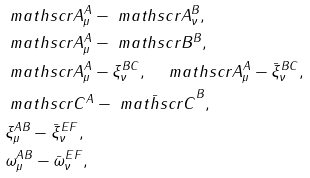<formula> <loc_0><loc_0><loc_500><loc_500>& \ m a t h s c r { A } _ { \mu } ^ { A } - \ m a t h s c r { A } _ { \nu } ^ { B } , \\ & \ m a t h s c r { A } _ { \mu } ^ { A } - \ m a t h s c r { B } ^ { B } , \\ & \ m a t h s c r { A } _ { \mu } ^ { A } - \xi _ { \nu } ^ { B C } , \quad \ m a t h s c r { A } _ { \mu } ^ { A } - \bar { \xi } _ { \nu } ^ { B C } , \\ & \ m a t h s c r { C } ^ { A } - \bar { \ m a t h s c r { C } } ^ { B } , \\ & \xi _ { \mu } ^ { A B } - \bar { \xi } _ { \nu } ^ { E F } , \\ & \omega _ { \mu } ^ { A B } - \bar { \omega } _ { \nu } ^ { E F } ,</formula> 